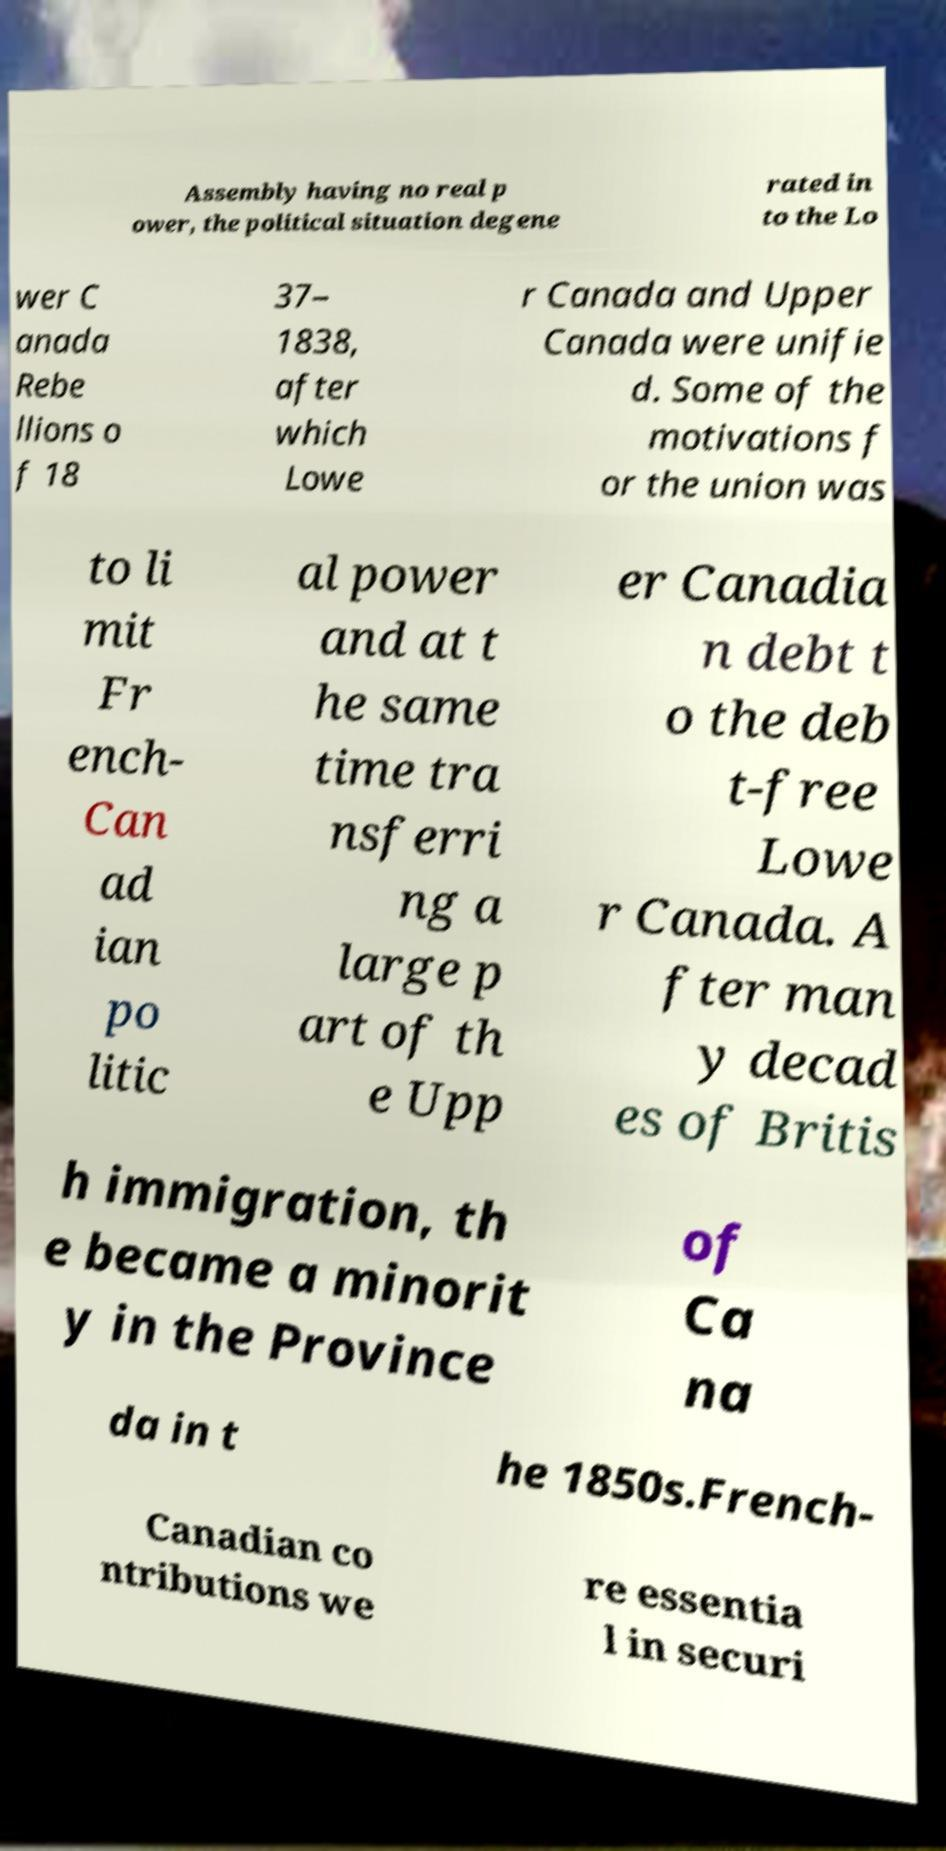I need the written content from this picture converted into text. Can you do that? Assembly having no real p ower, the political situation degene rated in to the Lo wer C anada Rebe llions o f 18 37– 1838, after which Lowe r Canada and Upper Canada were unifie d. Some of the motivations f or the union was to li mit Fr ench- Can ad ian po litic al power and at t he same time tra nsferri ng a large p art of th e Upp er Canadia n debt t o the deb t-free Lowe r Canada. A fter man y decad es of Britis h immigration, th e became a minorit y in the Province of Ca na da in t he 1850s.French- Canadian co ntributions we re essentia l in securi 